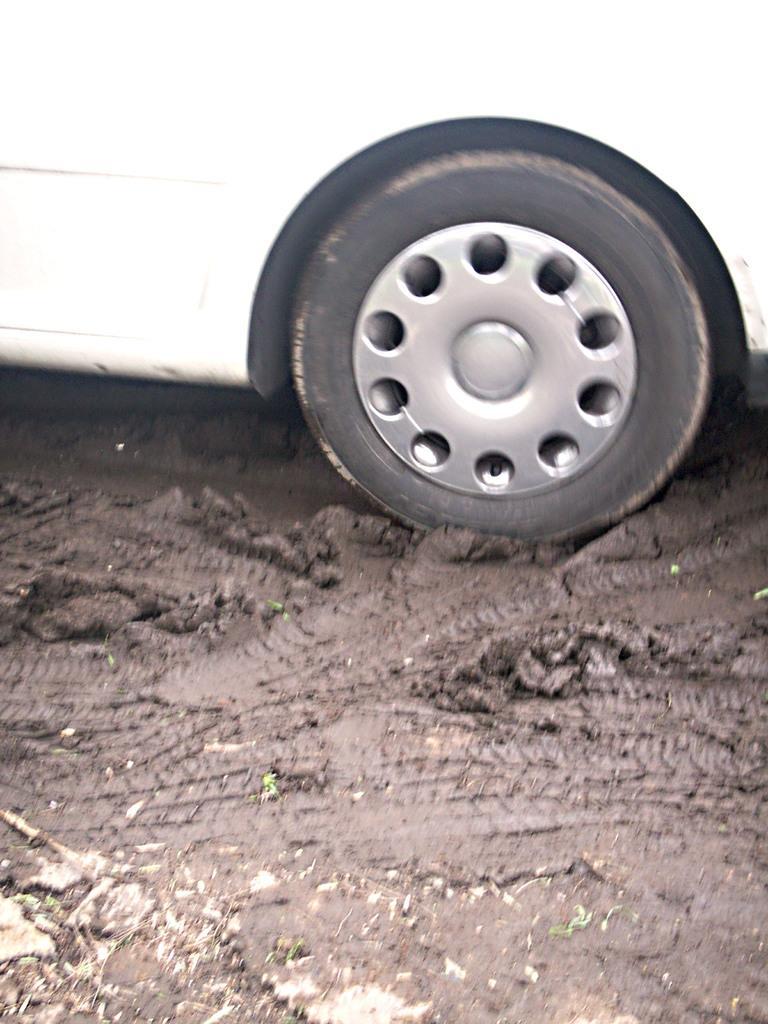Describe this image in one or two sentences. In this picture we can see a vehicle. At the bottom there is mud. 